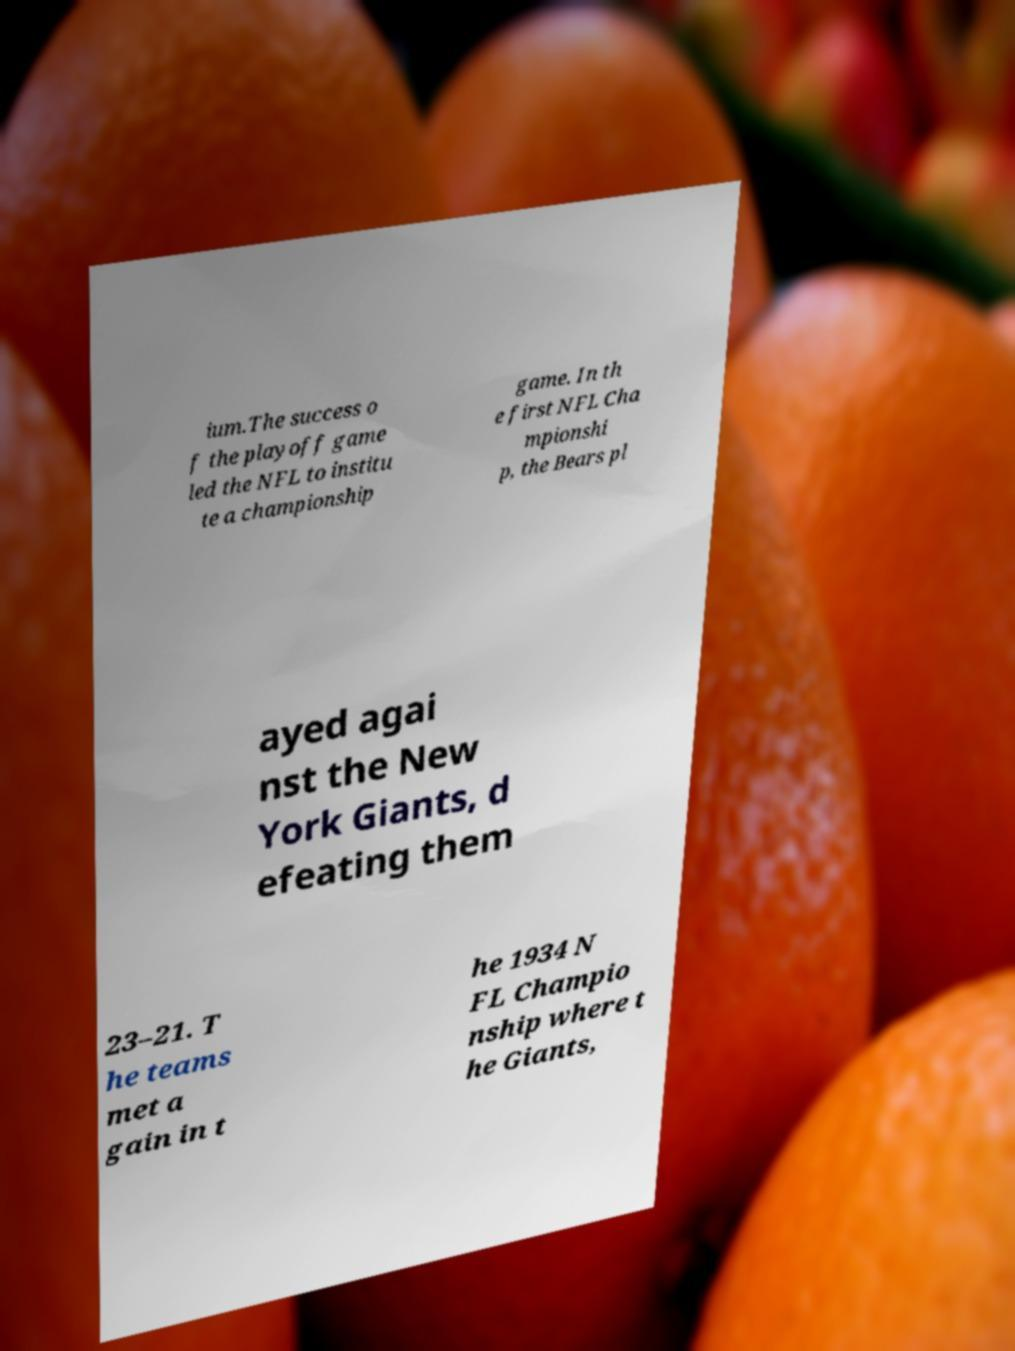Can you accurately transcribe the text from the provided image for me? ium.The success o f the playoff game led the NFL to institu te a championship game. In th e first NFL Cha mpionshi p, the Bears pl ayed agai nst the New York Giants, d efeating them 23–21. T he teams met a gain in t he 1934 N FL Champio nship where t he Giants, 